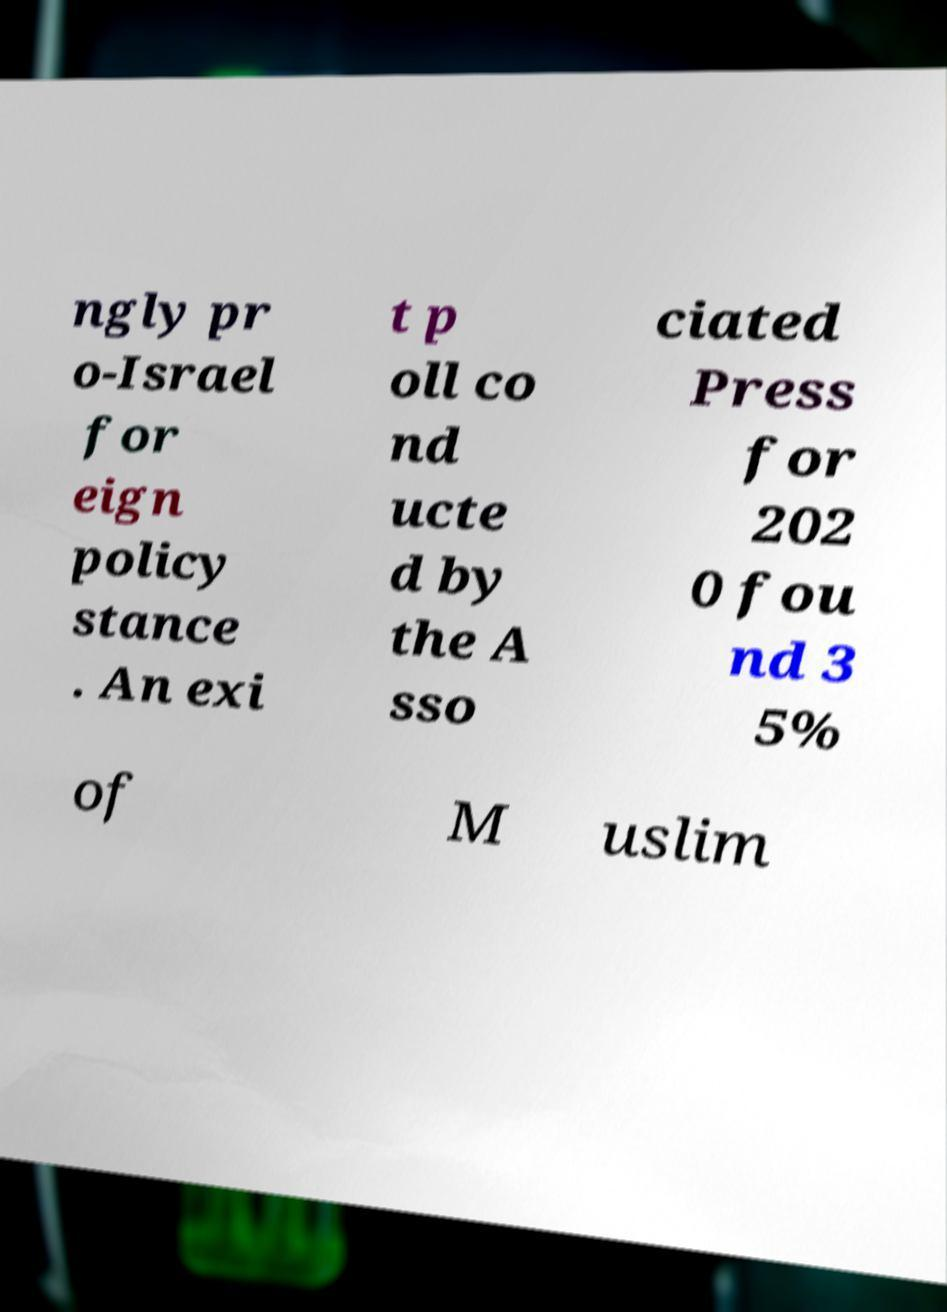Could you extract and type out the text from this image? ngly pr o-Israel for eign policy stance . An exi t p oll co nd ucte d by the A sso ciated Press for 202 0 fou nd 3 5% of M uslim 